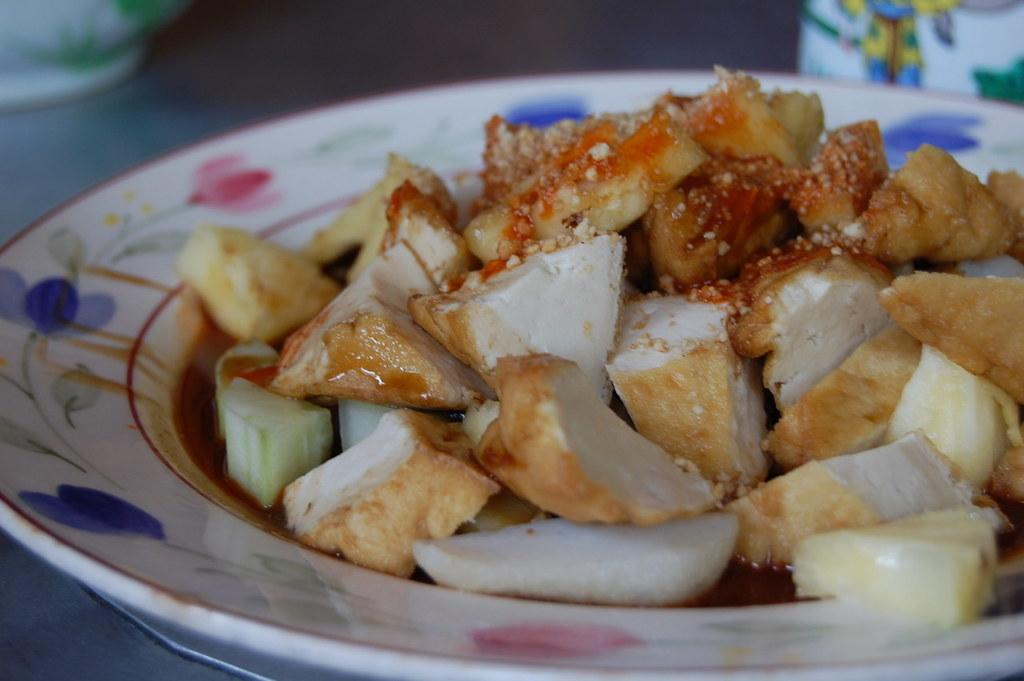What is on the plate that is visible in the image? There are food items on a white plate in the image. Where is the plate located? The plate is on a table in the image. What else can be seen on the table besides the plate? There are other vessels on the table in the image. What can be observed about the background of the image? The background of the image is dark in color. How does the beginner learn to cook the chicken in the image? There is no chicken or cooking activity present in the image, so it is not possible to answer that question. 